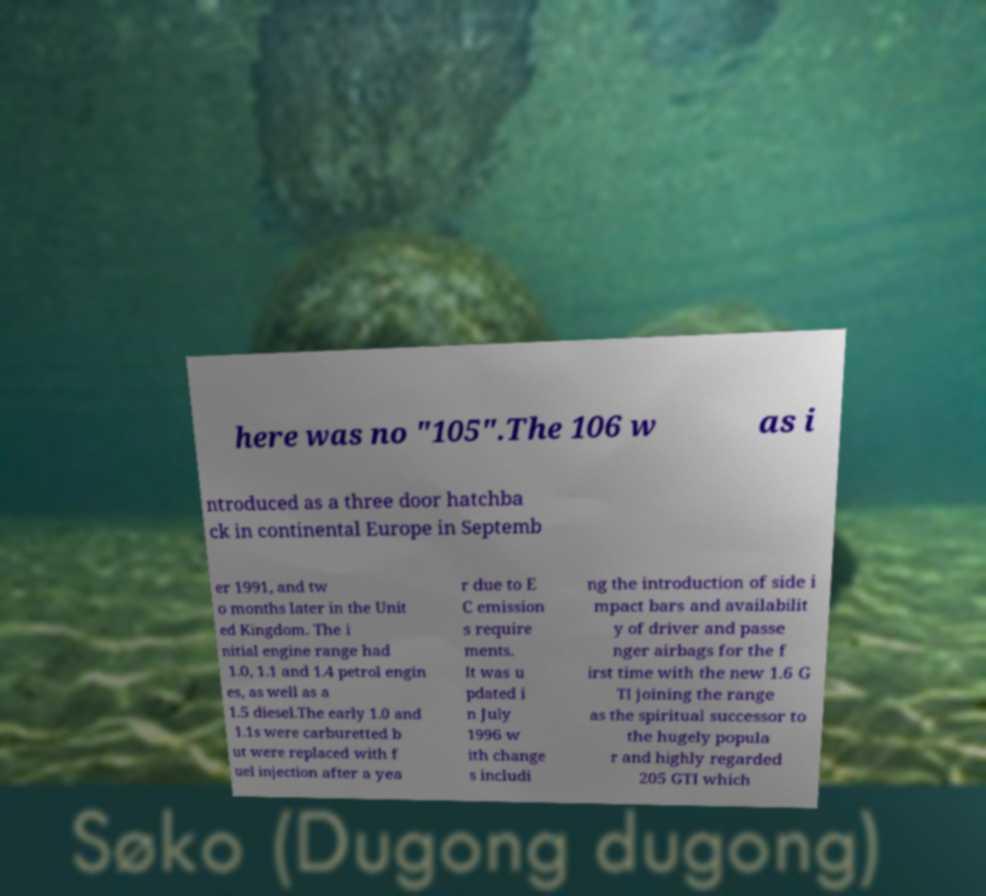What messages or text are displayed in this image? I need them in a readable, typed format. here was no "105".The 106 w as i ntroduced as a three door hatchba ck in continental Europe in Septemb er 1991, and tw o months later in the Unit ed Kingdom. The i nitial engine range had 1.0, 1.1 and 1.4 petrol engin es, as well as a 1.5 diesel.The early 1.0 and 1.1s were carburetted b ut were replaced with f uel injection after a yea r due to E C emission s require ments. It was u pdated i n July 1996 w ith change s includi ng the introduction of side i mpact bars and availabilit y of driver and passe nger airbags for the f irst time with the new 1.6 G TI joining the range as the spiritual successor to the hugely popula r and highly regarded 205 GTI which 